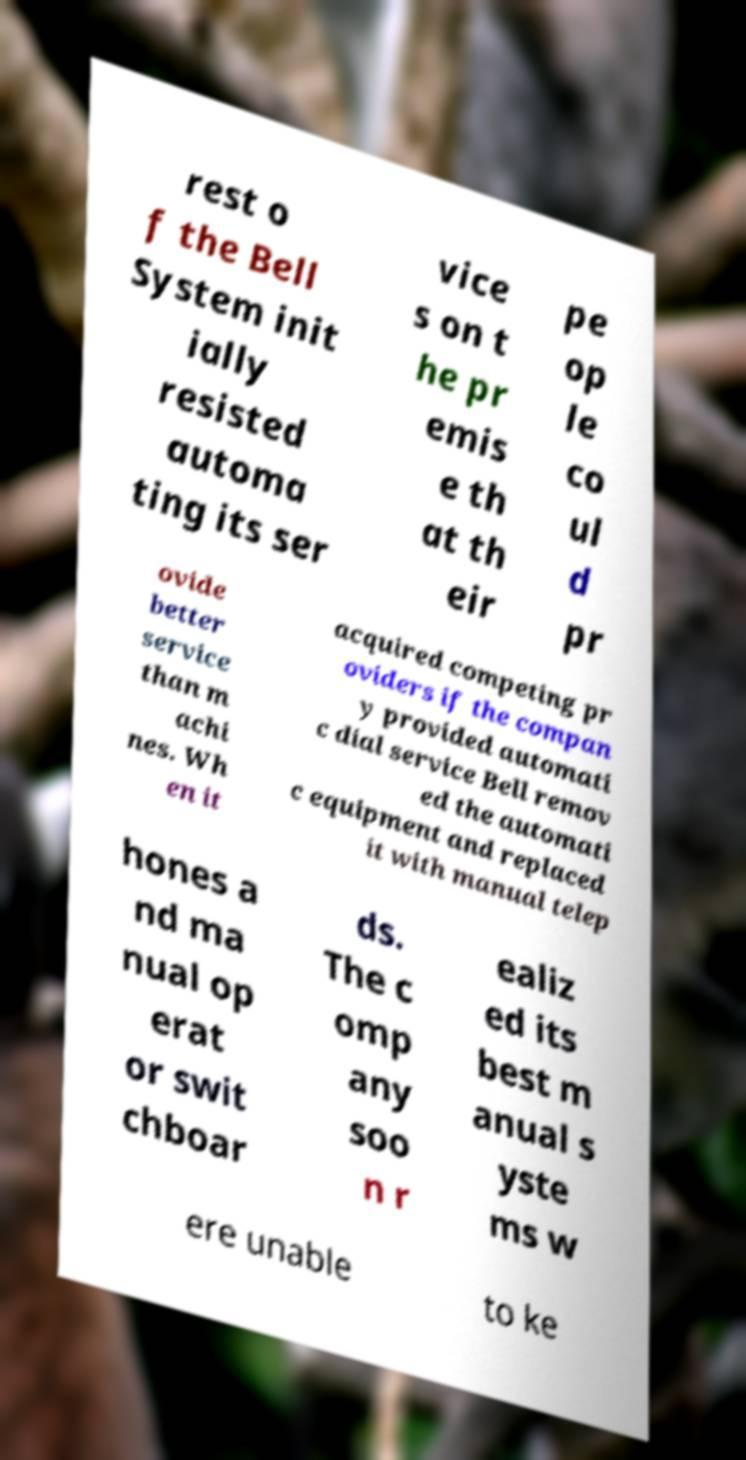What messages or text are displayed in this image? I need them in a readable, typed format. rest o f the Bell System init ially resisted automa ting its ser vice s on t he pr emis e th at th eir pe op le co ul d pr ovide better service than m achi nes. Wh en it acquired competing pr oviders if the compan y provided automati c dial service Bell remov ed the automati c equipment and replaced it with manual telep hones a nd ma nual op erat or swit chboar ds. The c omp any soo n r ealiz ed its best m anual s yste ms w ere unable to ke 